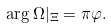Convert formula to latex. <formula><loc_0><loc_0><loc_500><loc_500>\arg \Omega | _ { \Xi } = \pi \varphi .</formula> 